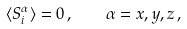Convert formula to latex. <formula><loc_0><loc_0><loc_500><loc_500>\langle S _ { i } ^ { \alpha } \rangle = 0 \, , \quad \alpha = x , y , z \, ,</formula> 